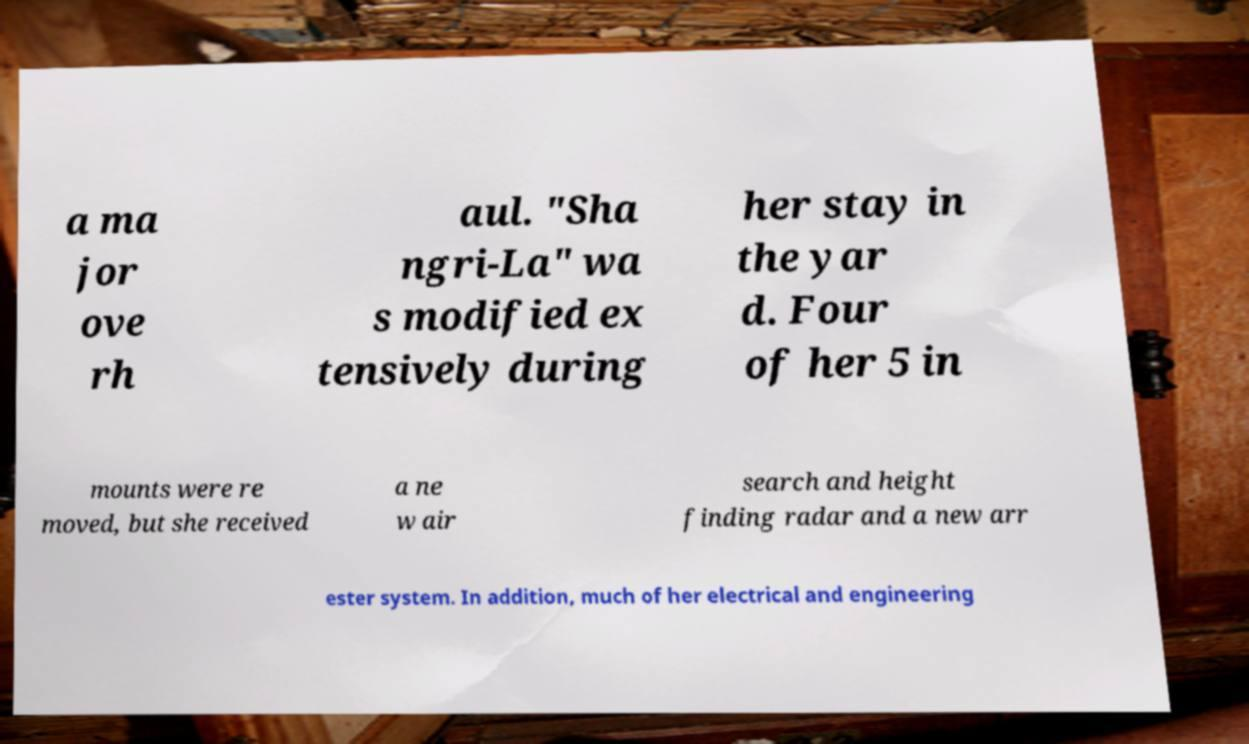Could you extract and type out the text from this image? a ma jor ove rh aul. "Sha ngri-La" wa s modified ex tensively during her stay in the yar d. Four of her 5 in mounts were re moved, but she received a ne w air search and height finding radar and a new arr ester system. In addition, much of her electrical and engineering 